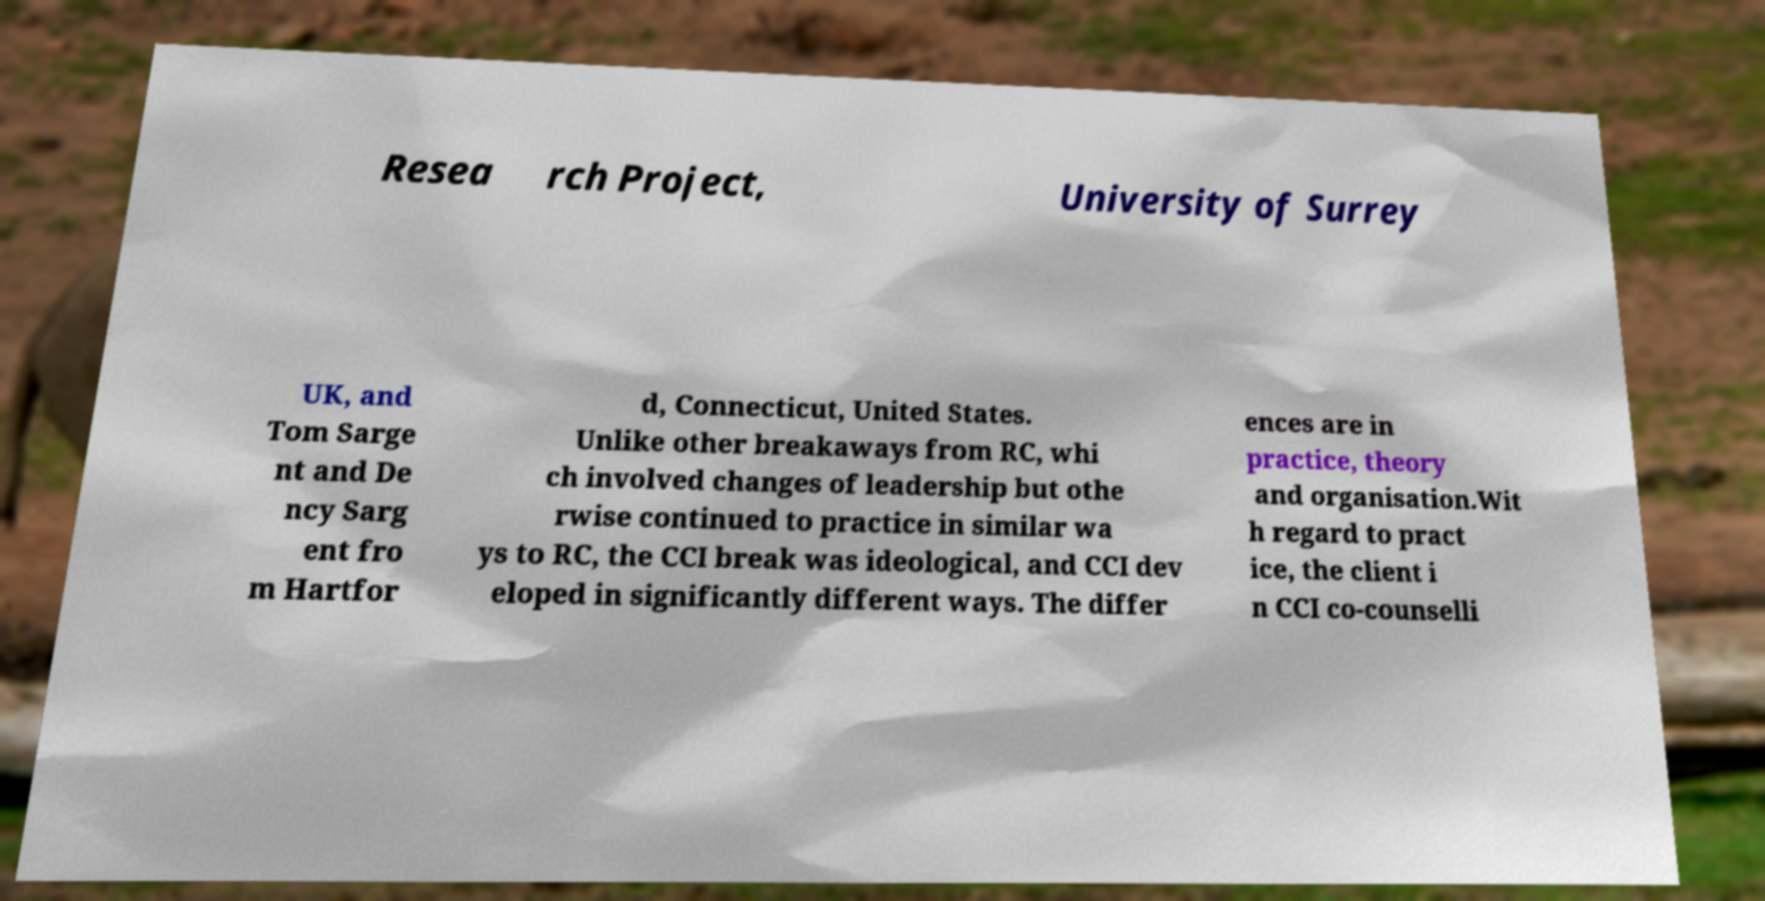Please identify and transcribe the text found in this image. Resea rch Project, University of Surrey UK, and Tom Sarge nt and De ncy Sarg ent fro m Hartfor d, Connecticut, United States. Unlike other breakaways from RC, whi ch involved changes of leadership but othe rwise continued to practice in similar wa ys to RC, the CCI break was ideological, and CCI dev eloped in significantly different ways. The differ ences are in practice, theory and organisation.Wit h regard to pract ice, the client i n CCI co-counselli 